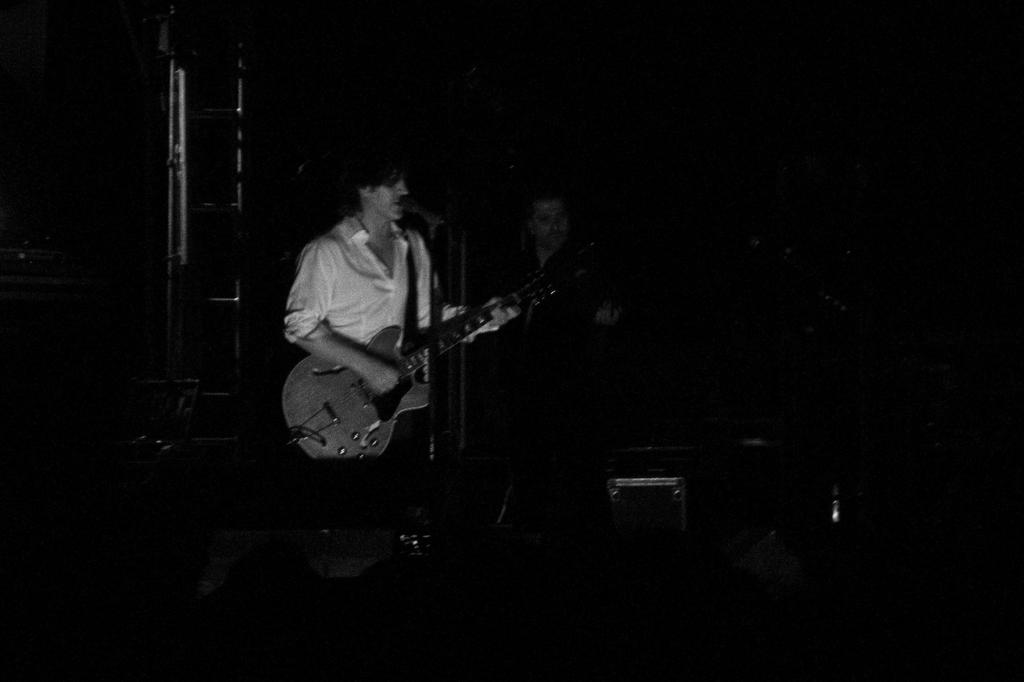How many people are in the image? There are 2 persons in the image. What are the persons doing in the image? The persons are standing and playing musical instruments. Can you describe anything in the background of the image? Yes, there is a ladder visible in the background of the image. What type of show can be seen happening in the image? There is no show visible in the image; it features two people playing musical instruments. What kind of noise is being produced by the mine in the image? There is no mine present in the image, so no noise can be attributed to it. 